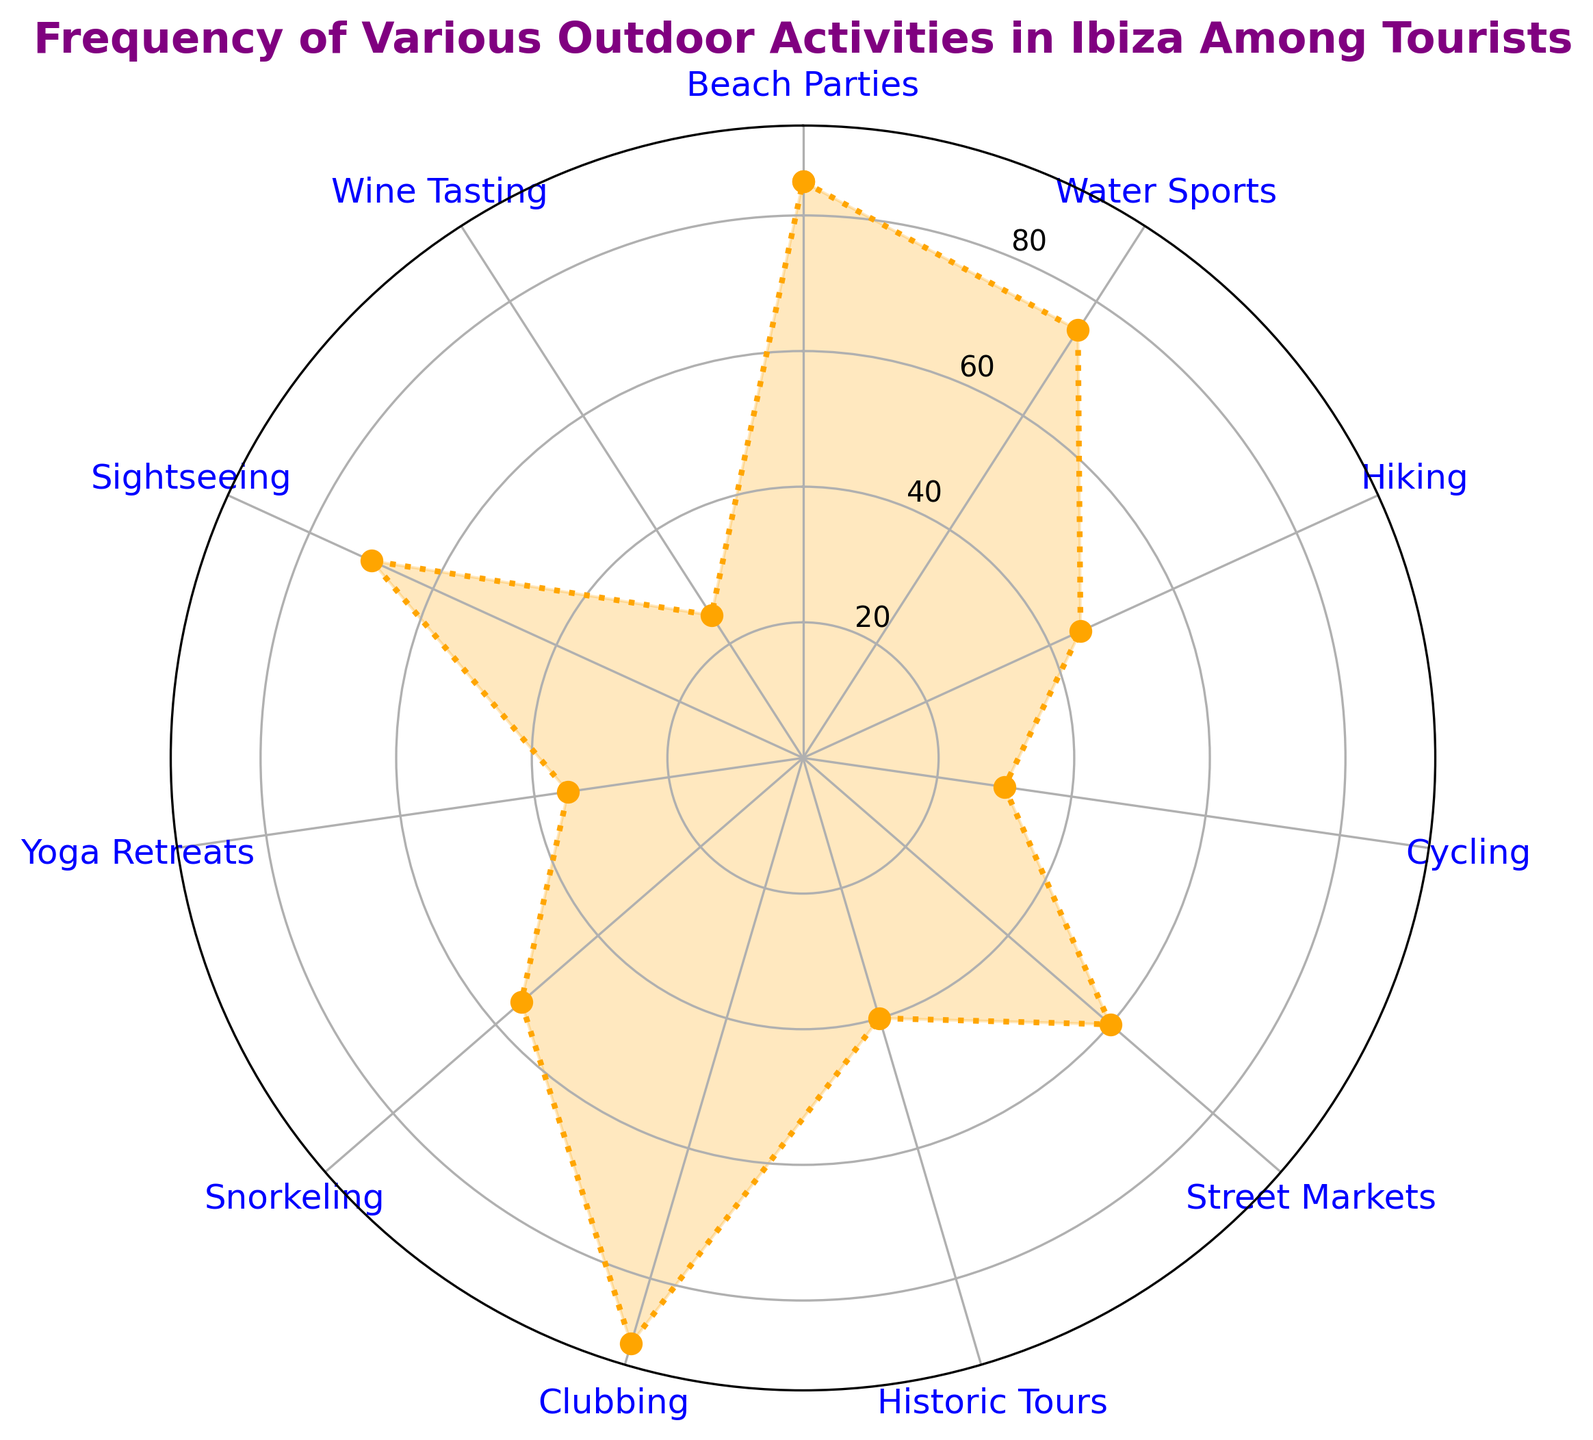What's the most popular activity among tourists in Ibiza? The radar chart shows the frequencies of various outdoor activities. The activity with the highest frequency is the most popular. Clubbing has the highest value on the chart.
Answer: Clubbing Which activity is less popular: Yoga Retreats or Historic Tours? On the radar chart, compare the values of Yoga Retreats and Historic Tours. Yoga Retreats has a frequency of 35, and Historic Tours has a frequency of 40.
Answer: Yoga Retreats By how much is the frequency of Beach Parties greater than the frequency of Hiking? Find the values of Beach Parties and Hiking on the radar chart. Beach Parties have a frequency of 85 and Hiking has a frequency of 45. Subtract the frequency of Hiking from Beach Parties: 85 - 45.
Answer: 40 What's the average frequency of the three most popular activities? Identify the top three activities by frequency (Clubbing: 90, Beach Parties: 85, Water Sports: 75). Calculate the average: (90 + 85 + 75) / 3.
Answer: 83.33 Which activity gets the least attention from tourists? The radar chart shows the frequencies of various activities. The activity with the lowest frequency has the least attention. Wine Tasting has the lowest value on the chart.
Answer: Wine Tasting How many more tourists prefer Street Markets over Cycling? Check the frequencies for Street Markets and Cycling on the radar chart. Street Markets have a frequency of 60, and Cycling has a frequency of 30. Subtract Cycling's frequency from Street Markets: 60 - 30.
Answer: 30 What is the total frequency of all water-related activities combined? Identify water-related activities and their frequencies: Water Sports (75), Snorkeling (55). Sum these frequencies: 75 + 55.
Answer: 130 What is the ratio of the frequency of Snorkeling to Wine Tasting? Find the frequencies of Snorkeling and Wine Tasting on the radar chart. Snorkeling has a frequency of 55, and Wine Tasting has a frequency of 25. Divide Snorkeling's frequency by Wine Tasting's frequency: 55 / 25.
Answer: 2.2 Which two activities have the closest frequencies to each other? Compare the frequencies of all activities on the radar chart. Hiking (45) and Historic Tours (40) are the closest. The difference is 5.
Answer: Hiking and Historic Tours What's the combined frequency of Sightseeing and Yoga Retreats? Check Sightseeing and Yoga Retreats frequencies on the radar chart. Sightseeing has a frequency of 70, and Yoga Retreats has a frequency of 35. Sum these frequencies: 70 + 35.
Answer: 105 